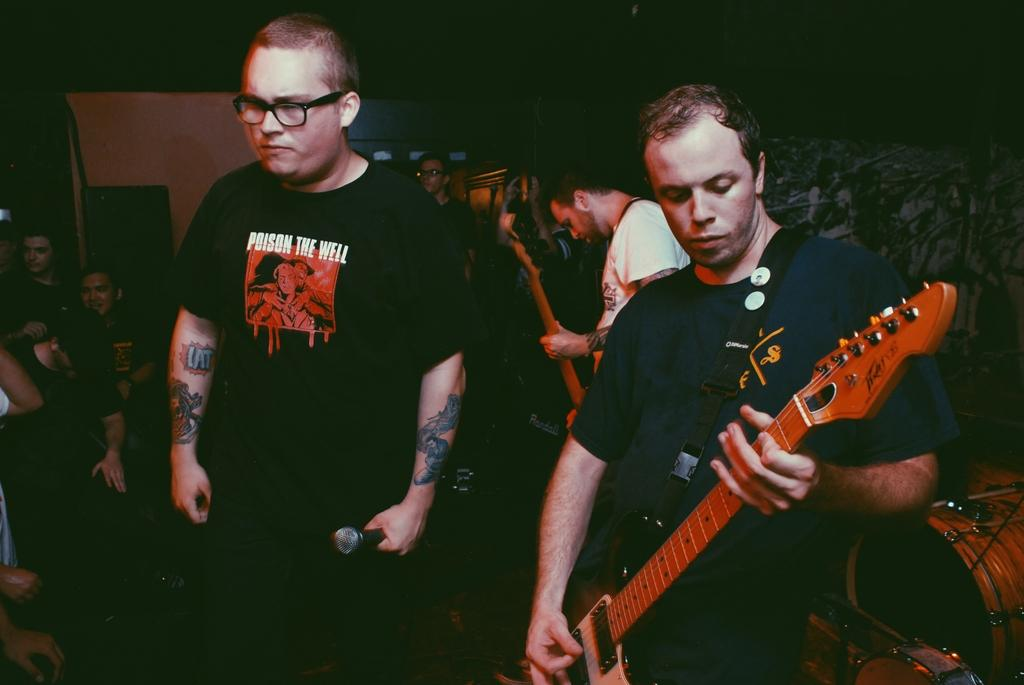What is the man in the image holding? The man is holding a microphone in the image. What is the person next to the man holding? The person next to the man is holding a guitar in the image. Can you describe the people visible in the background of the image? There are people visible in the background of the image, but their specific actions or features cannot be determined from the provided facts. How many giants can be seen in the image? There are no giants present in the image. What type of music is being played by the person holding the guitar in the image? The provided facts do not specify the type of music being played by the person holding the guitar in the image. --- Facts: 1. There is a car in the image. 2. The car is parked on the street. 3. There are trees visible in the background of the image. 4. The sky is visible in the image. Absurd Topics: parrot, sand, ocean Conversation: What is the main subject of the image? The main subject of the image is a car. Where is the car located in the image? The car is parked on the street in the image. What can be seen in the background of the image? Trees and the sky are visible in the background of the image. Reasoning: Let's think step by step in order to produce the conversation. We start by identifying the main subject of the image, which is the car. Then, we describe the car's location, noting that it is parked on the street. Finally, we describe the background of the image, which includes trees and the sky. We avoid yes/no questions and ensure that the language is simple and clear. Absurd Question/Answer: Can you see a parrot sitting on the car in the image? There is no parrot present in the image. Is the car parked near the ocean in the image? The provided facts do not mention the ocean or any body of water in the image. 